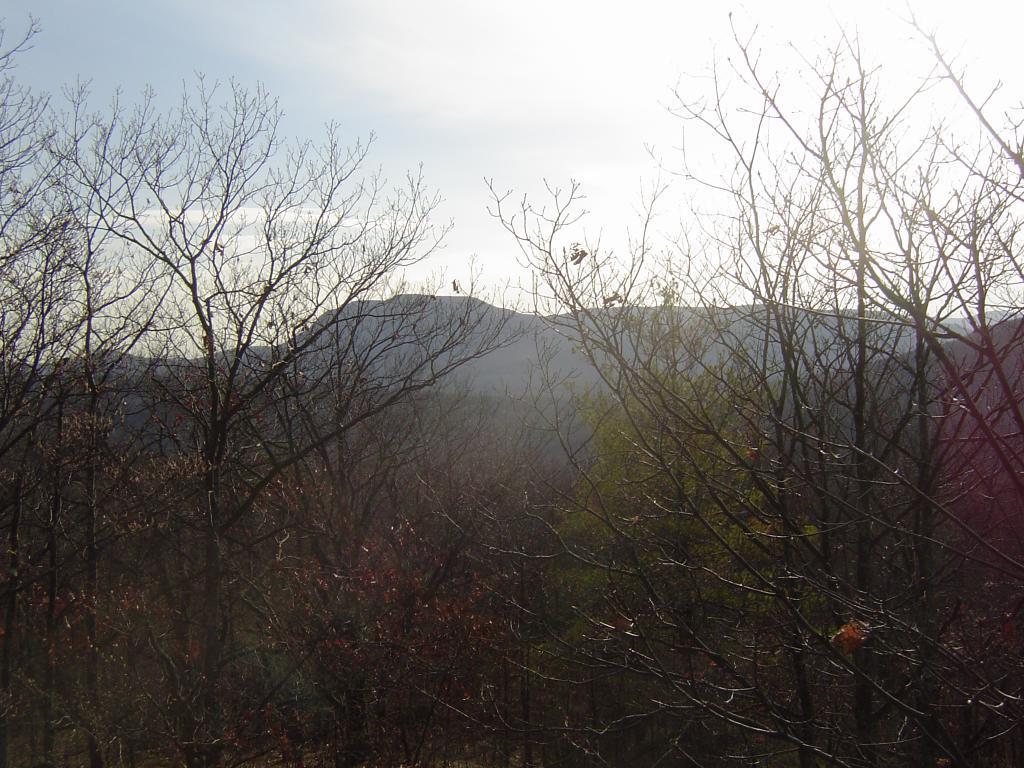Could you give a brief overview of what you see in this image? In this picture there are trees in the foreground. At the back there is a mountain. At the top there is sky and there are clouds. 